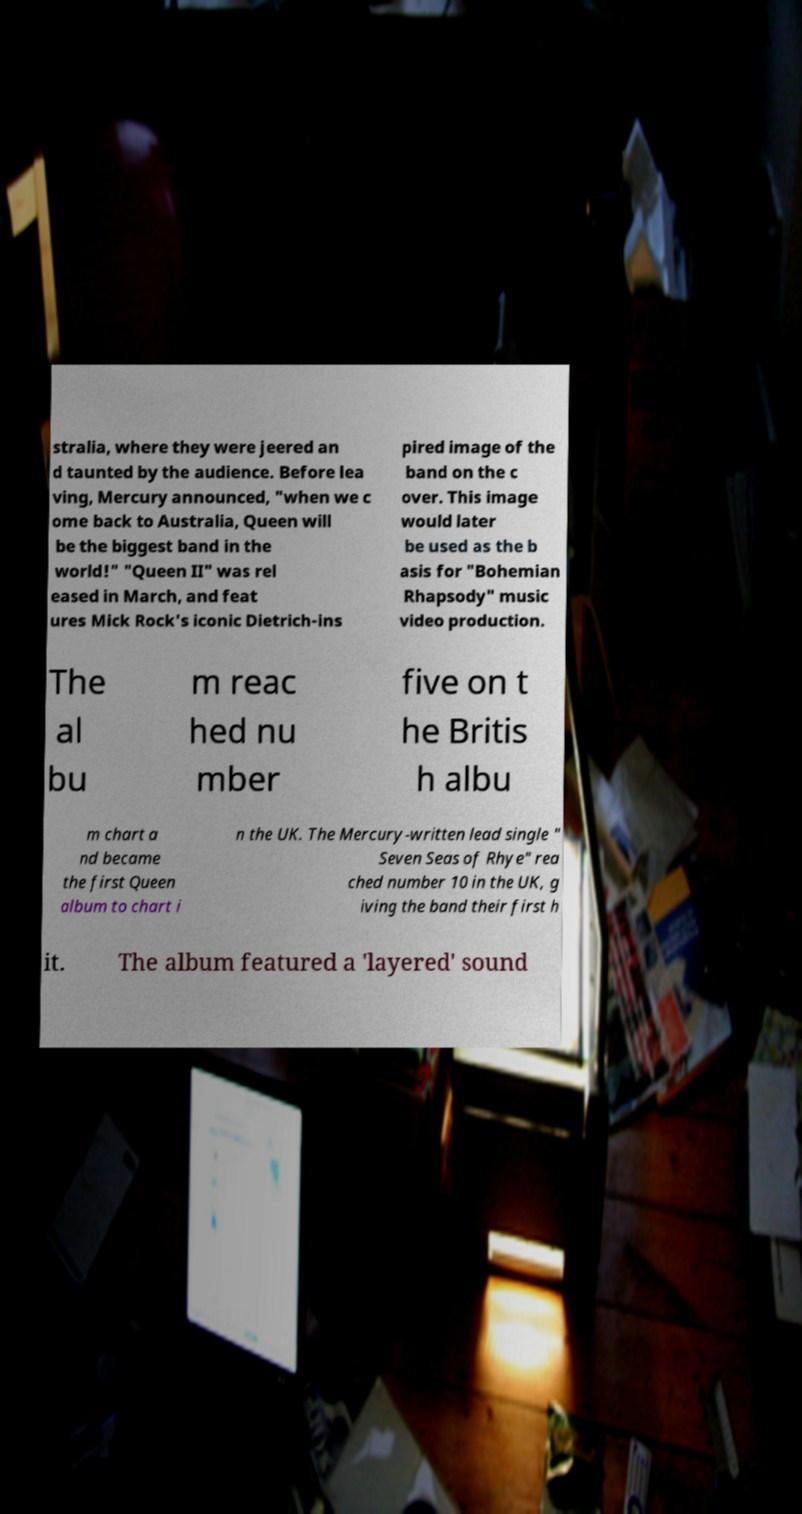Could you extract and type out the text from this image? stralia, where they were jeered an d taunted by the audience. Before lea ving, Mercury announced, "when we c ome back to Australia, Queen will be the biggest band in the world!" "Queen II" was rel eased in March, and feat ures Mick Rock's iconic Dietrich-ins pired image of the band on the c over. This image would later be used as the b asis for "Bohemian Rhapsody" music video production. The al bu m reac hed nu mber five on t he Britis h albu m chart a nd became the first Queen album to chart i n the UK. The Mercury-written lead single " Seven Seas of Rhye" rea ched number 10 in the UK, g iving the band their first h it. The album featured a 'layered' sound 